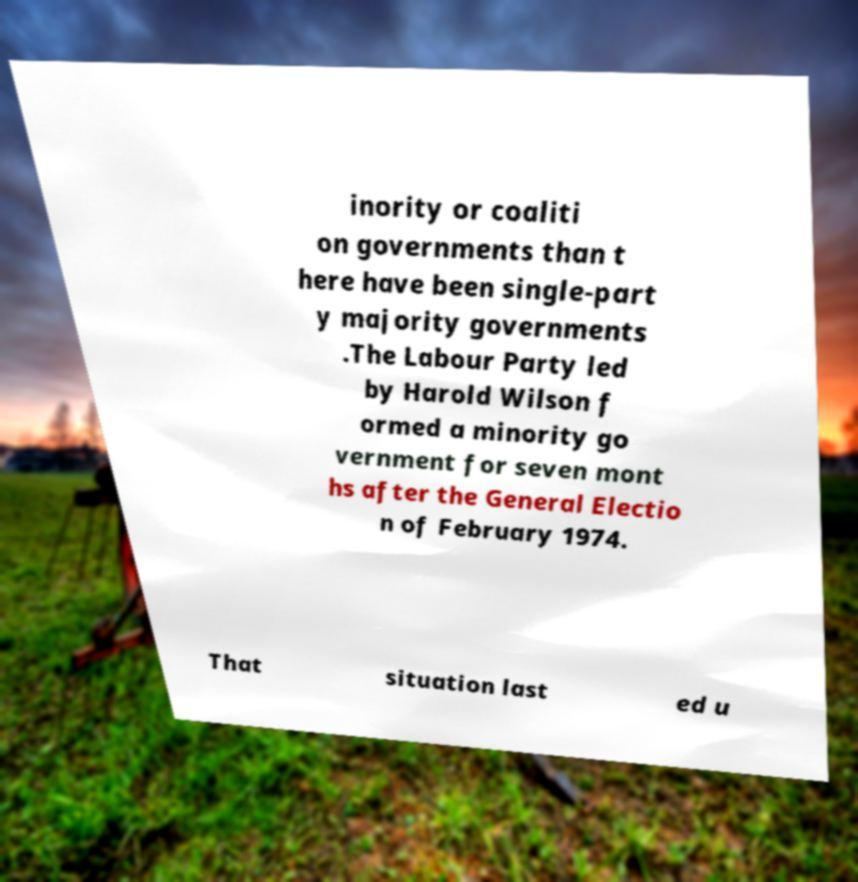What messages or text are displayed in this image? I need them in a readable, typed format. inority or coaliti on governments than t here have been single-part y majority governments .The Labour Party led by Harold Wilson f ormed a minority go vernment for seven mont hs after the General Electio n of February 1974. That situation last ed u 